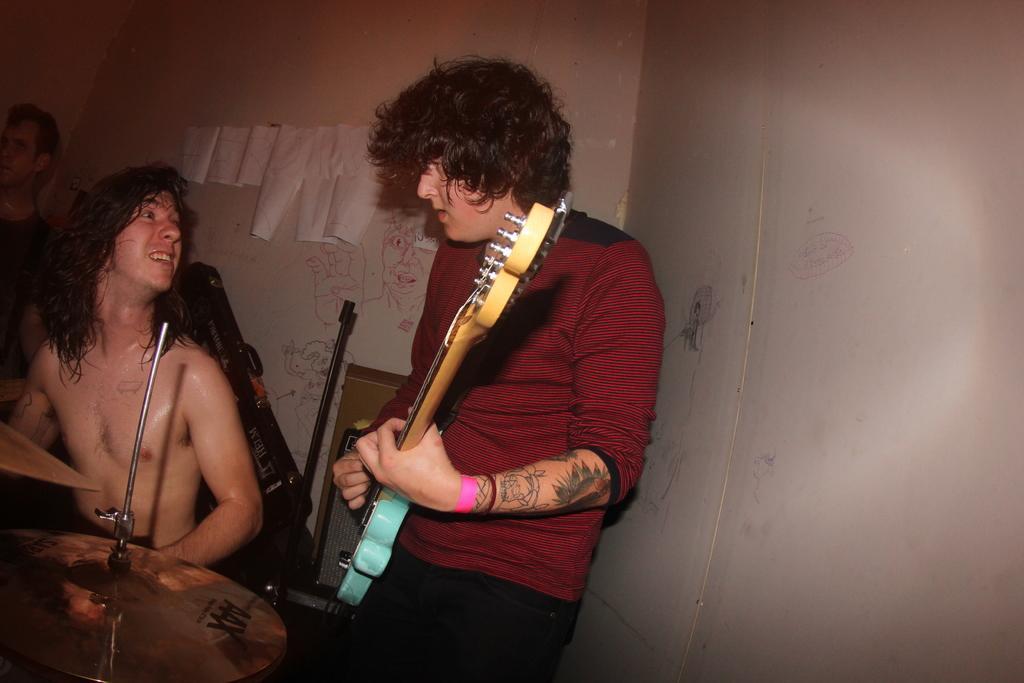Describe this image in one or two sentences. In this image I can see three people. Among them on person is holding the guitar and another person is sitting in front of the musical instrument. In the background the papers are attached to the wall. 